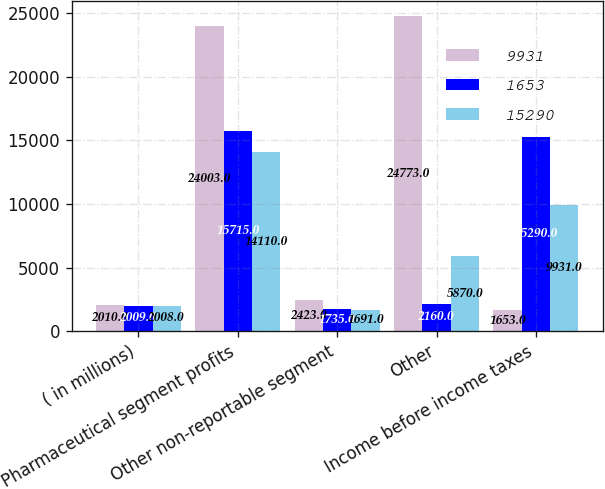Convert chart. <chart><loc_0><loc_0><loc_500><loc_500><stacked_bar_chart><ecel><fcel>( in millions)<fcel>Pharmaceutical segment profits<fcel>Other non-reportable segment<fcel>Other<fcel>Income before income taxes<nl><fcel>9931<fcel>2010<fcel>24003<fcel>2423<fcel>24773<fcel>1653<nl><fcel>1653<fcel>2009<fcel>15715<fcel>1735<fcel>2160<fcel>15290<nl><fcel>15290<fcel>2008<fcel>14110<fcel>1691<fcel>5870<fcel>9931<nl></chart> 